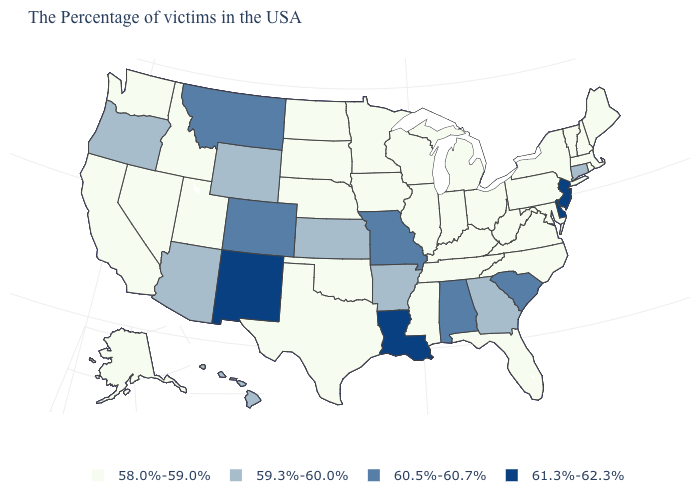Does West Virginia have the lowest value in the USA?
Concise answer only. Yes. What is the highest value in the USA?
Short answer required. 61.3%-62.3%. What is the value of Massachusetts?
Answer briefly. 58.0%-59.0%. Which states have the lowest value in the USA?
Be succinct. Maine, Massachusetts, Rhode Island, New Hampshire, Vermont, New York, Maryland, Pennsylvania, Virginia, North Carolina, West Virginia, Ohio, Florida, Michigan, Kentucky, Indiana, Tennessee, Wisconsin, Illinois, Mississippi, Minnesota, Iowa, Nebraska, Oklahoma, Texas, South Dakota, North Dakota, Utah, Idaho, Nevada, California, Washington, Alaska. Name the states that have a value in the range 58.0%-59.0%?
Concise answer only. Maine, Massachusetts, Rhode Island, New Hampshire, Vermont, New York, Maryland, Pennsylvania, Virginia, North Carolina, West Virginia, Ohio, Florida, Michigan, Kentucky, Indiana, Tennessee, Wisconsin, Illinois, Mississippi, Minnesota, Iowa, Nebraska, Oklahoma, Texas, South Dakota, North Dakota, Utah, Idaho, Nevada, California, Washington, Alaska. Name the states that have a value in the range 58.0%-59.0%?
Concise answer only. Maine, Massachusetts, Rhode Island, New Hampshire, Vermont, New York, Maryland, Pennsylvania, Virginia, North Carolina, West Virginia, Ohio, Florida, Michigan, Kentucky, Indiana, Tennessee, Wisconsin, Illinois, Mississippi, Minnesota, Iowa, Nebraska, Oklahoma, Texas, South Dakota, North Dakota, Utah, Idaho, Nevada, California, Washington, Alaska. Which states hav the highest value in the Northeast?
Write a very short answer. New Jersey. What is the highest value in the West ?
Quick response, please. 61.3%-62.3%. What is the lowest value in the USA?
Give a very brief answer. 58.0%-59.0%. Which states have the lowest value in the USA?
Keep it brief. Maine, Massachusetts, Rhode Island, New Hampshire, Vermont, New York, Maryland, Pennsylvania, Virginia, North Carolina, West Virginia, Ohio, Florida, Michigan, Kentucky, Indiana, Tennessee, Wisconsin, Illinois, Mississippi, Minnesota, Iowa, Nebraska, Oklahoma, Texas, South Dakota, North Dakota, Utah, Idaho, Nevada, California, Washington, Alaska. Name the states that have a value in the range 60.5%-60.7%?
Concise answer only. South Carolina, Alabama, Missouri, Colorado, Montana. What is the highest value in states that border North Carolina?
Concise answer only. 60.5%-60.7%. Which states have the highest value in the USA?
Concise answer only. New Jersey, Delaware, Louisiana, New Mexico. Does the map have missing data?
Write a very short answer. No. 